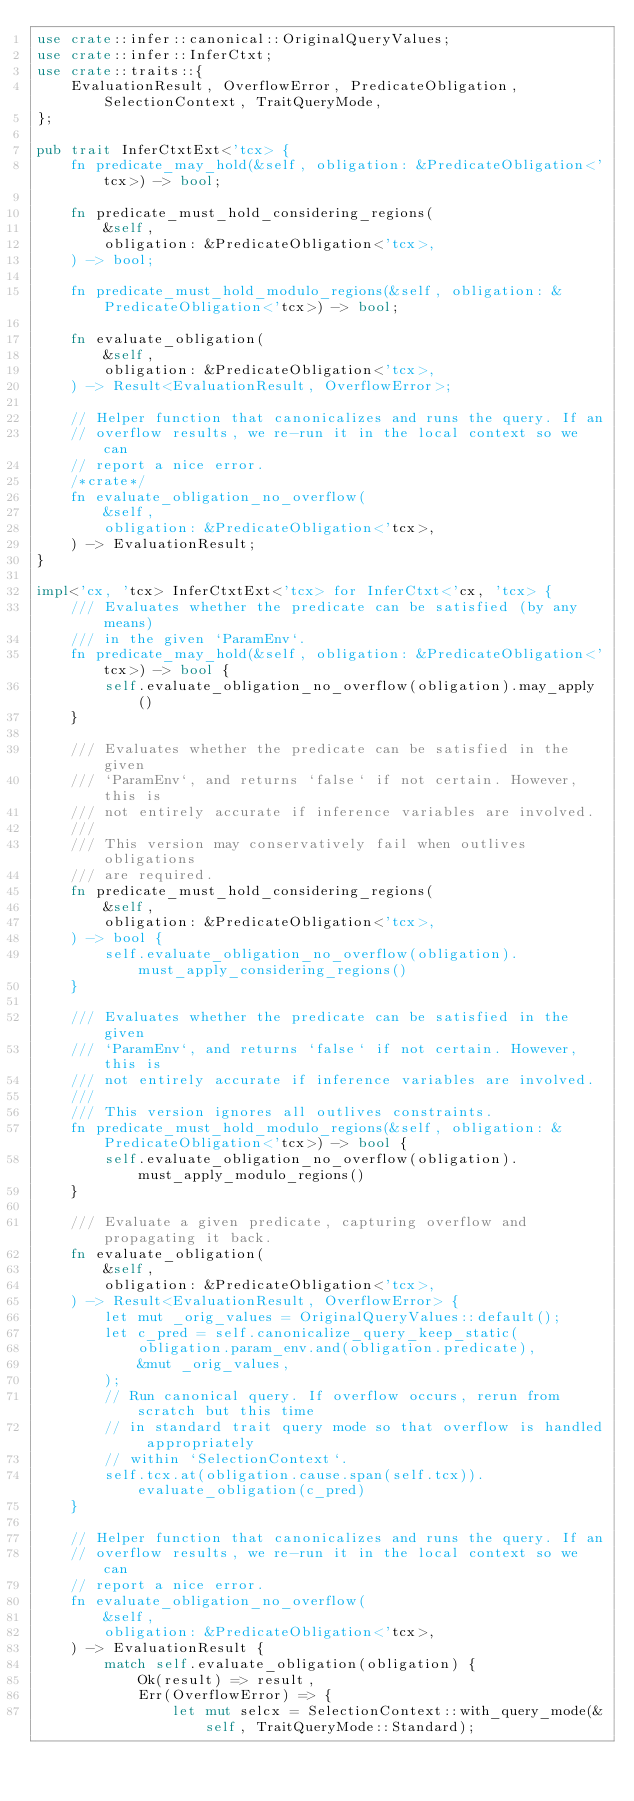Convert code to text. <code><loc_0><loc_0><loc_500><loc_500><_Rust_>use crate::infer::canonical::OriginalQueryValues;
use crate::infer::InferCtxt;
use crate::traits::{
    EvaluationResult, OverflowError, PredicateObligation, SelectionContext, TraitQueryMode,
};

pub trait InferCtxtExt<'tcx> {
    fn predicate_may_hold(&self, obligation: &PredicateObligation<'tcx>) -> bool;

    fn predicate_must_hold_considering_regions(
        &self,
        obligation: &PredicateObligation<'tcx>,
    ) -> bool;

    fn predicate_must_hold_modulo_regions(&self, obligation: &PredicateObligation<'tcx>) -> bool;

    fn evaluate_obligation(
        &self,
        obligation: &PredicateObligation<'tcx>,
    ) -> Result<EvaluationResult, OverflowError>;

    // Helper function that canonicalizes and runs the query. If an
    // overflow results, we re-run it in the local context so we can
    // report a nice error.
    /*crate*/
    fn evaluate_obligation_no_overflow(
        &self,
        obligation: &PredicateObligation<'tcx>,
    ) -> EvaluationResult;
}

impl<'cx, 'tcx> InferCtxtExt<'tcx> for InferCtxt<'cx, 'tcx> {
    /// Evaluates whether the predicate can be satisfied (by any means)
    /// in the given `ParamEnv`.
    fn predicate_may_hold(&self, obligation: &PredicateObligation<'tcx>) -> bool {
        self.evaluate_obligation_no_overflow(obligation).may_apply()
    }

    /// Evaluates whether the predicate can be satisfied in the given
    /// `ParamEnv`, and returns `false` if not certain. However, this is
    /// not entirely accurate if inference variables are involved.
    ///
    /// This version may conservatively fail when outlives obligations
    /// are required.
    fn predicate_must_hold_considering_regions(
        &self,
        obligation: &PredicateObligation<'tcx>,
    ) -> bool {
        self.evaluate_obligation_no_overflow(obligation).must_apply_considering_regions()
    }

    /// Evaluates whether the predicate can be satisfied in the given
    /// `ParamEnv`, and returns `false` if not certain. However, this is
    /// not entirely accurate if inference variables are involved.
    ///
    /// This version ignores all outlives constraints.
    fn predicate_must_hold_modulo_regions(&self, obligation: &PredicateObligation<'tcx>) -> bool {
        self.evaluate_obligation_no_overflow(obligation).must_apply_modulo_regions()
    }

    /// Evaluate a given predicate, capturing overflow and propagating it back.
    fn evaluate_obligation(
        &self,
        obligation: &PredicateObligation<'tcx>,
    ) -> Result<EvaluationResult, OverflowError> {
        let mut _orig_values = OriginalQueryValues::default();
        let c_pred = self.canonicalize_query_keep_static(
            obligation.param_env.and(obligation.predicate),
            &mut _orig_values,
        );
        // Run canonical query. If overflow occurs, rerun from scratch but this time
        // in standard trait query mode so that overflow is handled appropriately
        // within `SelectionContext`.
        self.tcx.at(obligation.cause.span(self.tcx)).evaluate_obligation(c_pred)
    }

    // Helper function that canonicalizes and runs the query. If an
    // overflow results, we re-run it in the local context so we can
    // report a nice error.
    fn evaluate_obligation_no_overflow(
        &self,
        obligation: &PredicateObligation<'tcx>,
    ) -> EvaluationResult {
        match self.evaluate_obligation(obligation) {
            Ok(result) => result,
            Err(OverflowError) => {
                let mut selcx = SelectionContext::with_query_mode(&self, TraitQueryMode::Standard);</code> 